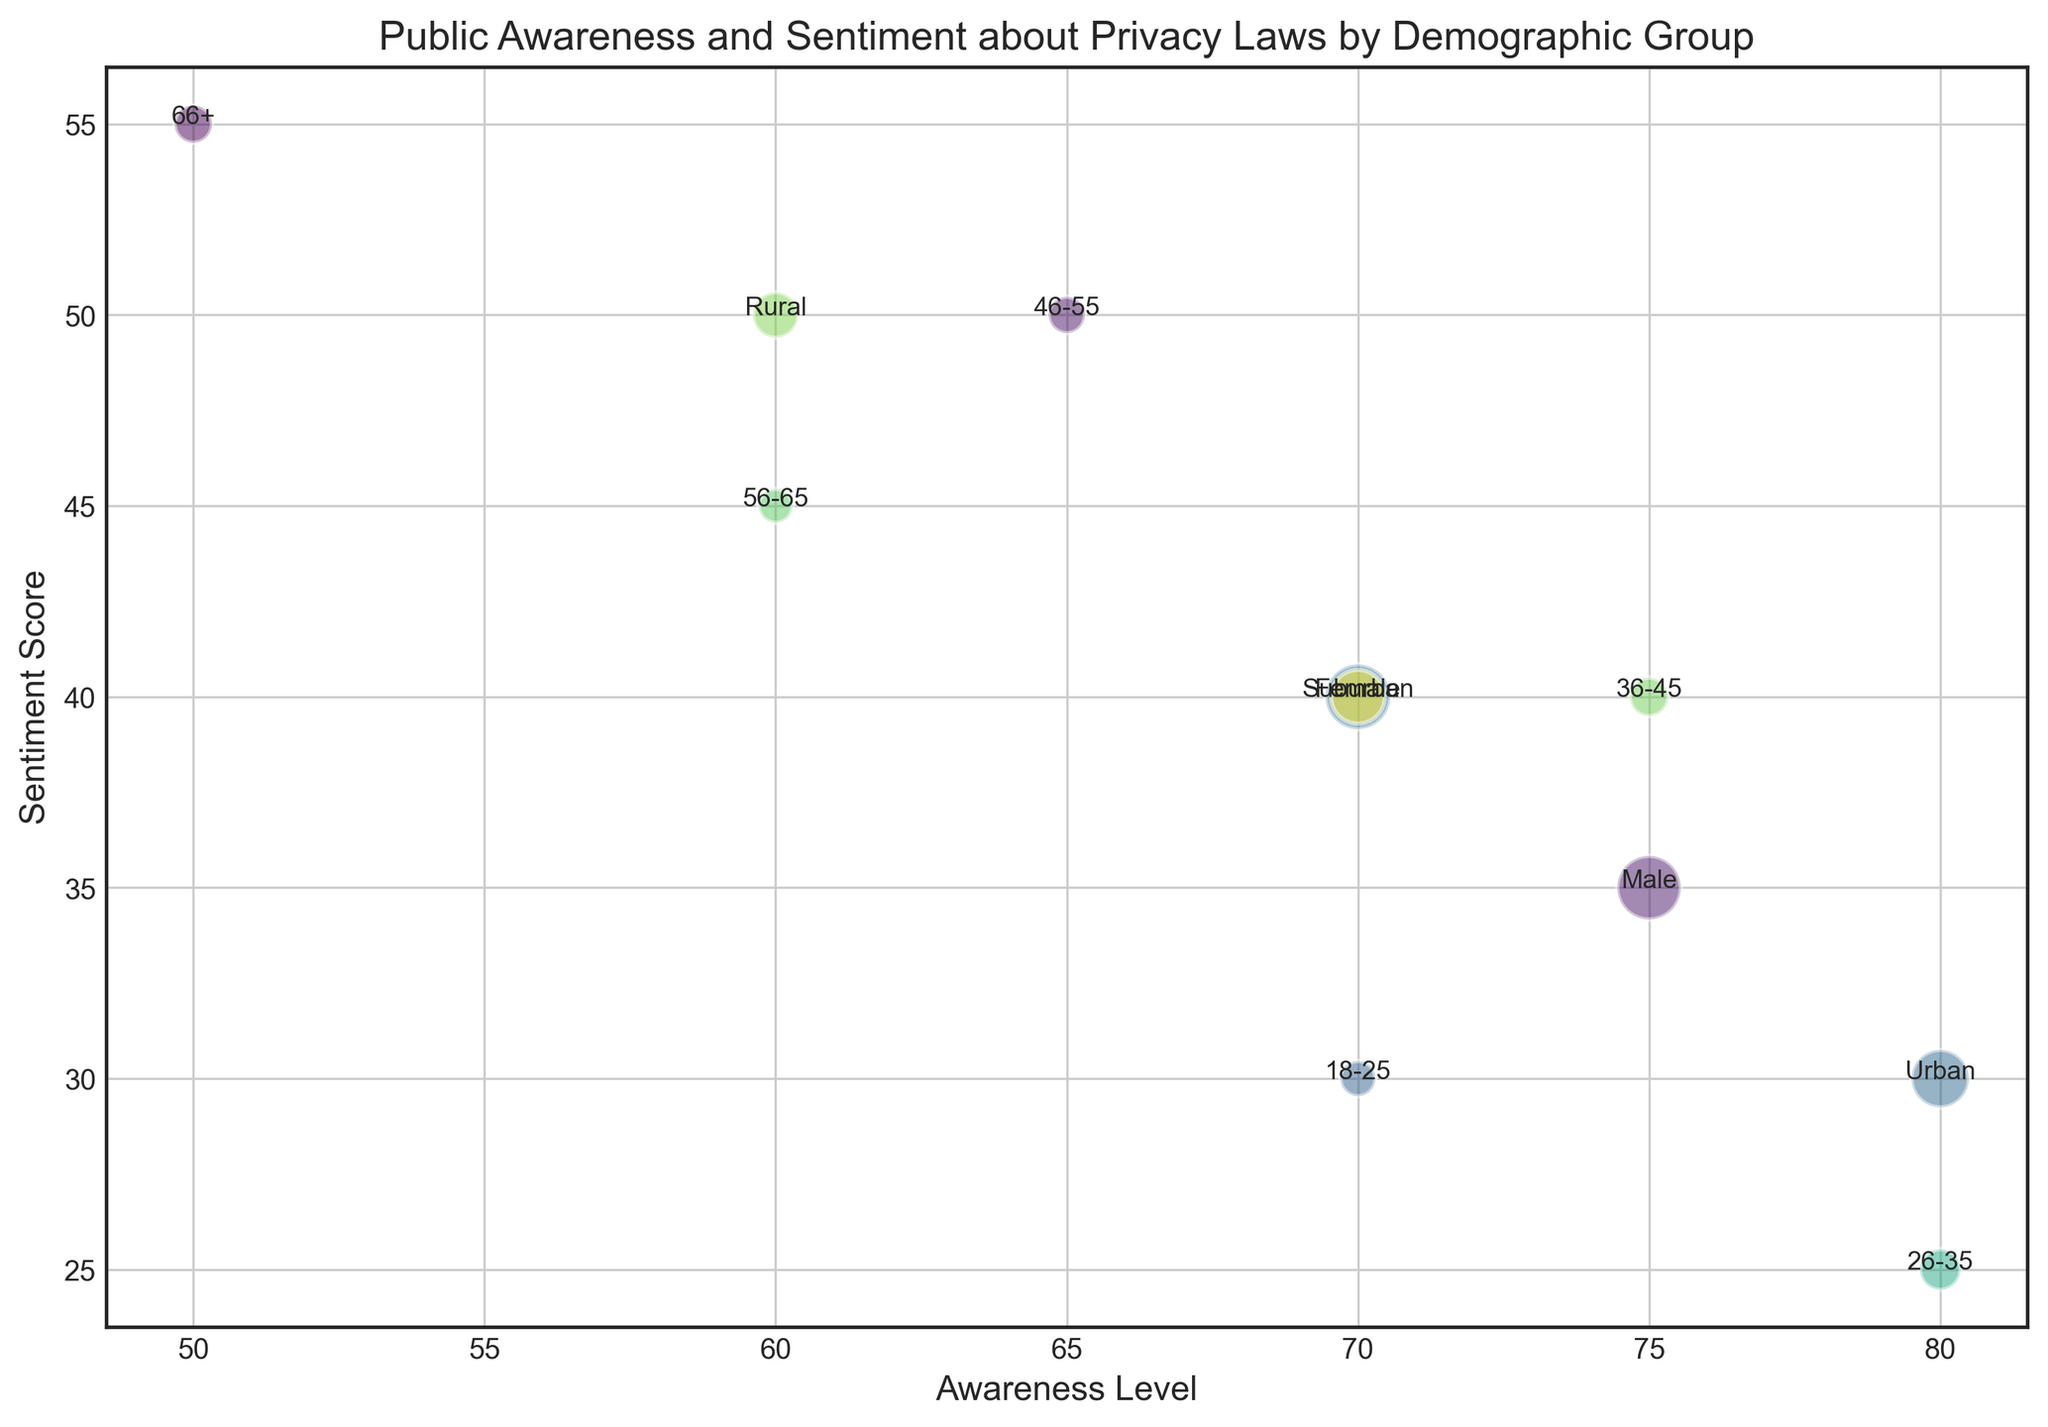Which demographic group has the highest awareness level? By observing the x-axis (Awareness Level), the bubble farthest to the right represents the highest awareness level. The group labeled next to it is marked as "Urban" with an awareness level of 80.
Answer: Urban What is the difference in the sentiment score between the 36-45 and 66+ age groups? Locate the bubbles for the 36-45 and 66+ age groups by their labels. Their positions on the y-axis (Sentiment Score) are 40 for the 36-45 group and 55 for the 66+ group. Calculate the difference: 55 - 40 = 15.
Answer: 15 What is the average awareness level of the age groups above 45? Check the awareness levels of the age groups 46-55, 56-65, and 66+, which are 65, 60, and 50 respectively. Calculate the average: (65 + 60 + 50) / 3 = 175 / 3 ≈ 58.33.
Answer: 58.33 Which gender group has a higher sentiment score? Compare the male and female sentiment scores. The male group has a sentiment score of 35, while the female group has a sentiment score of 40. Therefore, the Female group has a higher score.
Answer: Female What is the combined population percentage of the 18-25 and 26-35 age groups? Locate the population percentages for 18-25 and 26-35 groups, which are 15% and 20% respectively. Add these values: 15 + 20 = 35.
Answer: 35 Which demographic group in the rural category has the highest sentiment score? In the demographic labeled as "Rural", check the bubble for its sentiment score on the y-axis, which is 50. This group has the highest sentiment score in the rural category.
Answer: Rural How does the sentiment score of suburban residents compare to the overall average sentiment score of the age groups? Calculate the overall average sentiment score of all age groups (30 + 25 + 40 + 50 + 45 + 55) / 6 = 245 / 6 ≈ 40.83. The suburban sentiment score is 40. Compare these scores: 40 is slightly lower than 40.83.
Answer: Suburban residents have a slightly lower sentiment score Which demographic group has the largest bubble and what does it represent? Identify the largest bubble on the plot, check the annotated label next to it, and relate it to its population percentage value. The largest bubble belongs to the "Female" group with a 51% population percentage.
Answer: Female (51%) 